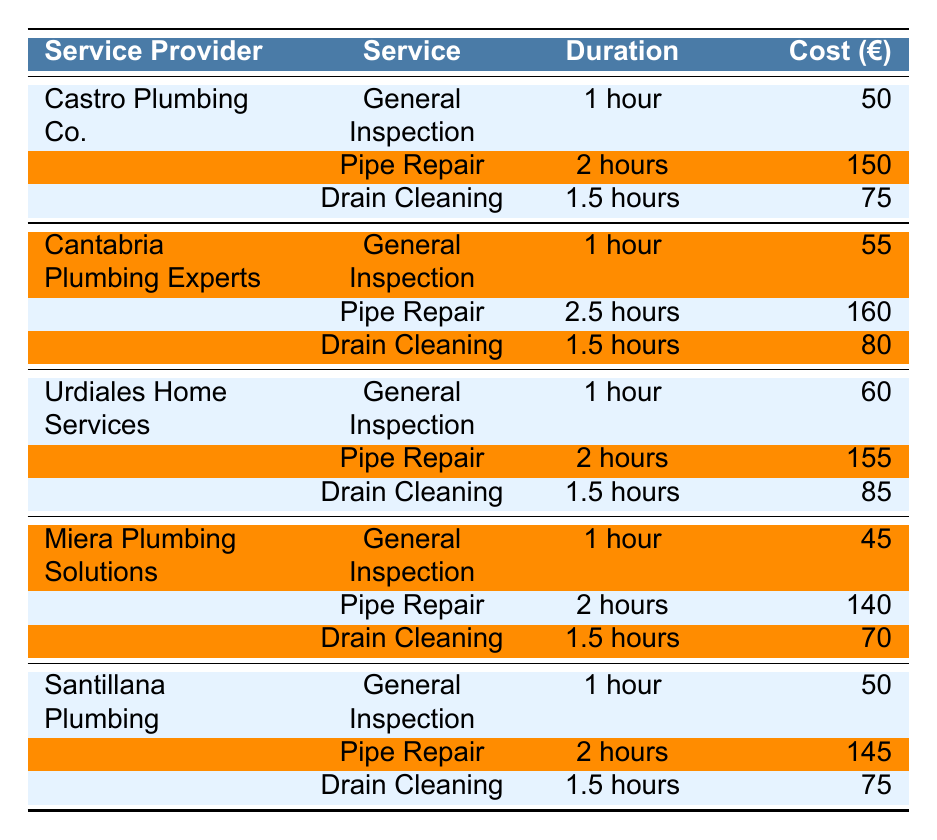What is the cost of a General Inspection from Miera Plumbing Solutions? The table shows that Miera Plumbing Solutions charges 45 euros for a General Inspection.
Answer: 45 Which plumbing service provider offers the most expensive Pipe Repair service? By comparing the costs of the Pipe Repair services from all providers, Cantabria Plumbing Experts charges the highest at 160 euros.
Answer: Cantabria Plumbing Experts What is the average cost of Drain Cleaning services across all providers? To find the average cost, add the costs of Drain Cleaning (75 + 80 + 85 + 70 + 75 = 385) and divide by the number of providers (5). So, 385/5 = 77.
Answer: 77 Is the cost of Pipe Repair from Urdiales Home Services lower than that from Castro Plumbing Co.? Urdiales Home Services charges 155 euros for Pipe Repair, whereas Castro Plumbing Co. charges 150 euros. Since 155 is higher than 150, this statement is false.
Answer: No How much more does Cantabria Plumbing Experts charge for Pipe Repair compared to Miera Plumbing Solutions? Cantabria Plumbing Experts charges 160 euros and Miera Plumbing Solutions charges 140 euros. The difference is 160 - 140 = 20 euros.
Answer: 20 